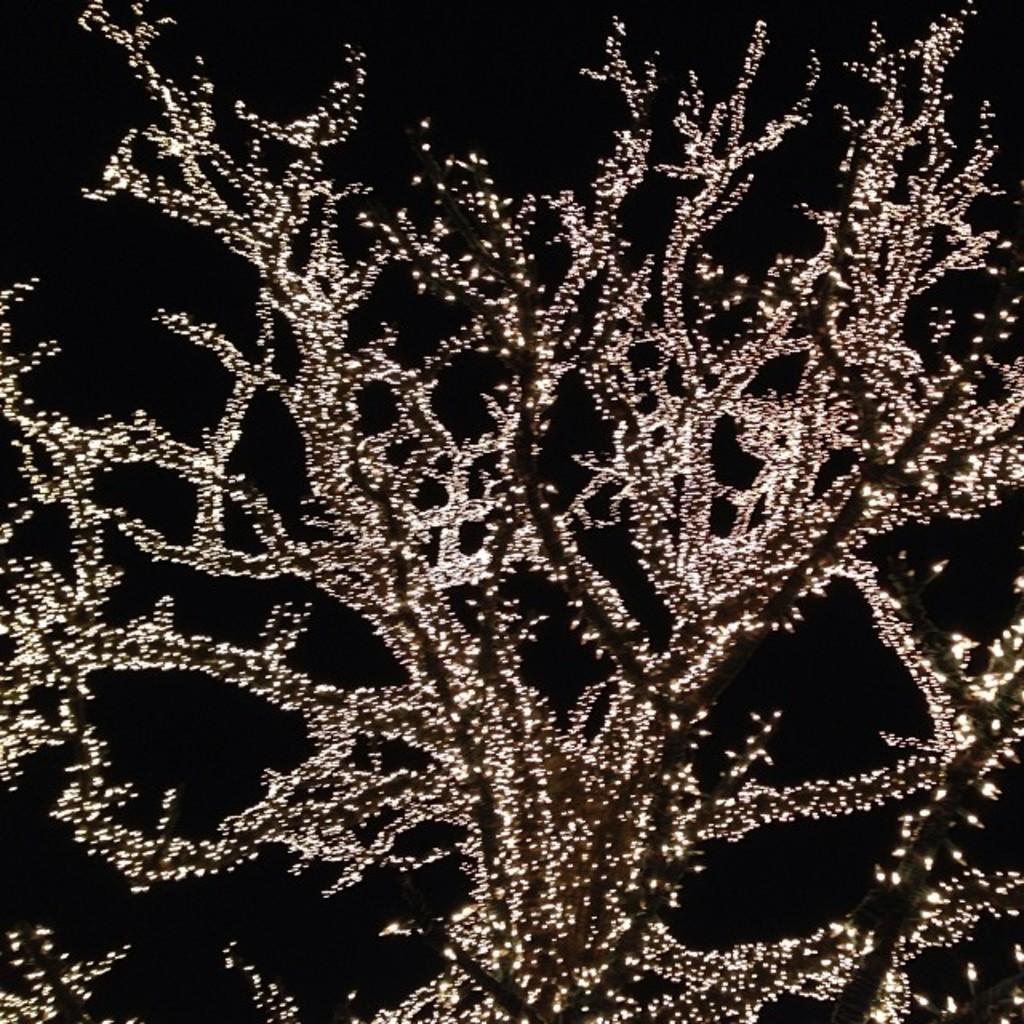Can you describe this image briefly? In this image we can see a tree with some decorative lights. In the background of the image there is a black background. 